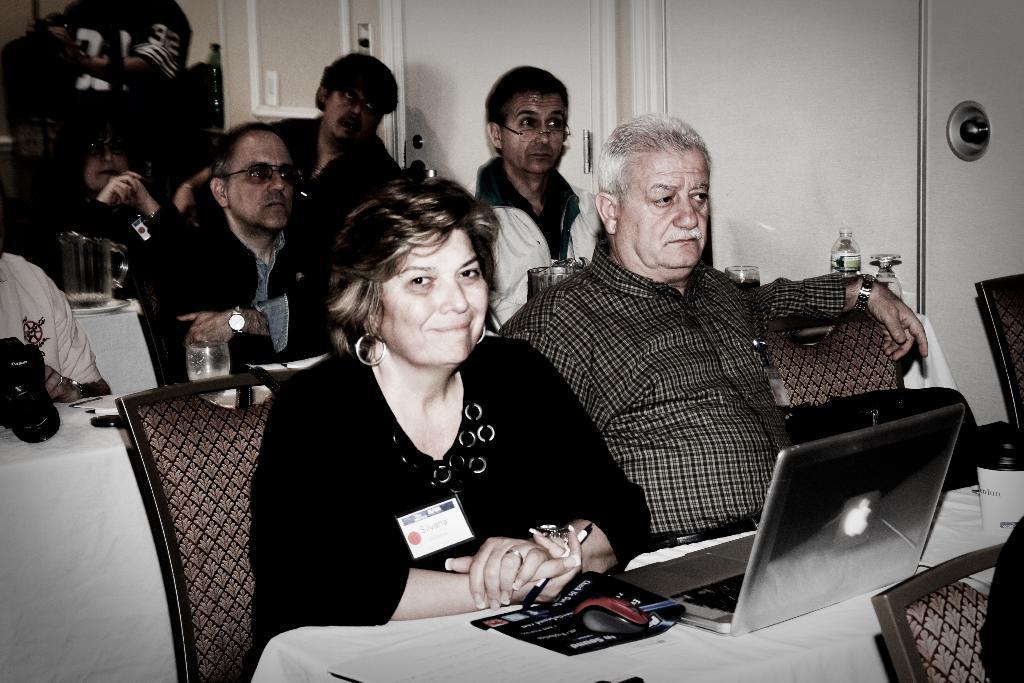How would you summarize this image in a sentence or two? In this picture I can see few people seated and I can see laptop and a mouse on the table and few glasses, water bottle and a camera on another table and a glass jar and i can see a man standing on the back and few doors on the side. 